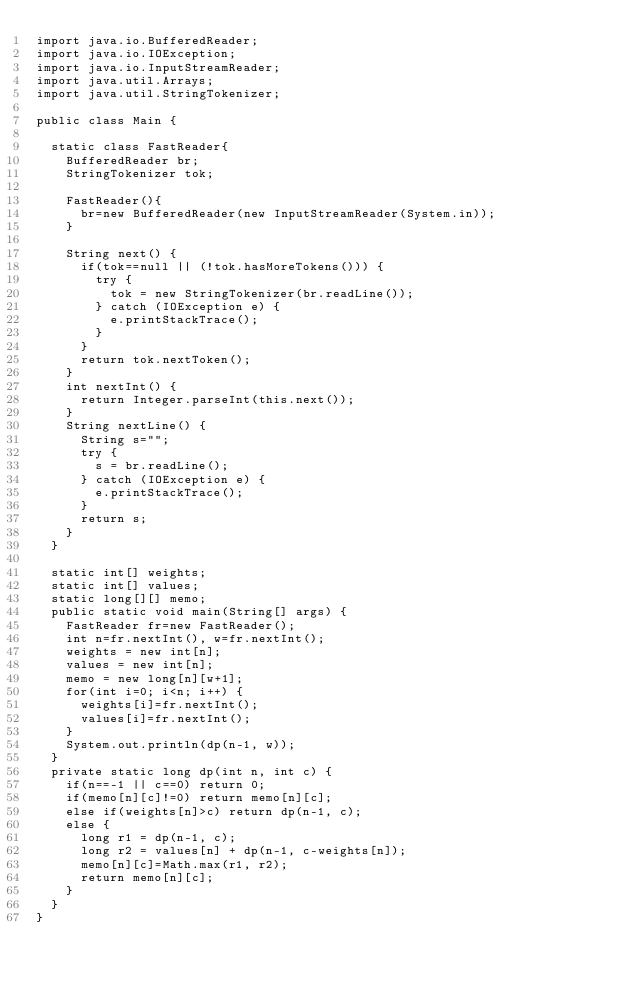<code> <loc_0><loc_0><loc_500><loc_500><_Java_>import java.io.BufferedReader;
import java.io.IOException;
import java.io.InputStreamReader;
import java.util.Arrays;
import java.util.StringTokenizer;

public class Main {
	
	static class FastReader{
		BufferedReader br;
		StringTokenizer tok;
		
		FastReader(){
			br=new BufferedReader(new InputStreamReader(System.in));
		}
		
		String next() {
			if(tok==null || (!tok.hasMoreTokens())) {
				try {
					tok = new StringTokenizer(br.readLine());
				} catch (IOException e) {
					e.printStackTrace();
				}
			}
			return tok.nextToken();
		}
		int nextInt() {
			return Integer.parseInt(this.next());
		}
		String nextLine() {
			String s="";
			try {
				s = br.readLine();
			} catch (IOException e) {
				e.printStackTrace();
			}
			return s;
		}
	}
	
	static int[] weights;
	static int[] values;
	static long[][] memo;
	public static void main(String[] args) {
		FastReader fr=new FastReader();
		int n=fr.nextInt(), w=fr.nextInt();
		weights = new int[n];
		values = new int[n];
		memo = new long[n][w+1];
		for(int i=0; i<n; i++) {
			weights[i]=fr.nextInt();
			values[i]=fr.nextInt();
		}
		System.out.println(dp(n-1, w));
	}
	private static long dp(int n, int c) {
		if(n==-1 || c==0) return 0;
		if(memo[n][c]!=0) return memo[n][c];
		else if(weights[n]>c) return dp(n-1, c);
		else {
			long r1 = dp(n-1, c);
			long r2 = values[n] + dp(n-1, c-weights[n]);
			memo[n][c]=Math.max(r1, r2);
			return memo[n][c];
		}
	}
}
</code> 